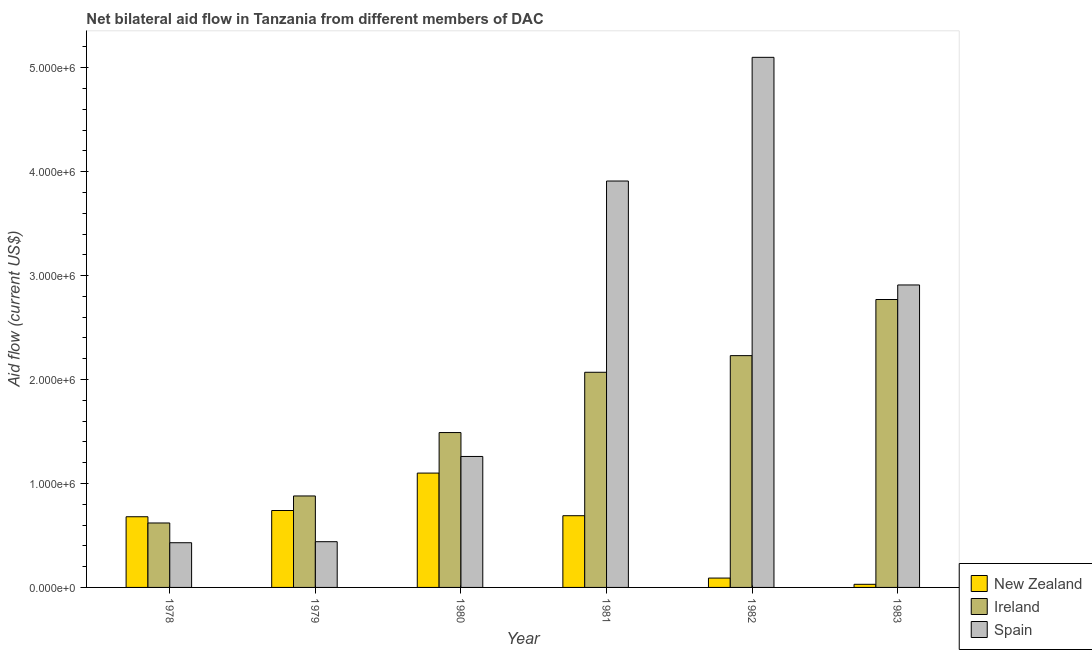How many groups of bars are there?
Offer a very short reply. 6. Are the number of bars per tick equal to the number of legend labels?
Keep it short and to the point. Yes. How many bars are there on the 5th tick from the left?
Offer a terse response. 3. What is the label of the 3rd group of bars from the left?
Your answer should be very brief. 1980. What is the amount of aid provided by spain in 1980?
Provide a short and direct response. 1.26e+06. Across all years, what is the maximum amount of aid provided by spain?
Give a very brief answer. 5.10e+06. Across all years, what is the minimum amount of aid provided by ireland?
Keep it short and to the point. 6.20e+05. In which year was the amount of aid provided by ireland minimum?
Offer a terse response. 1978. What is the total amount of aid provided by spain in the graph?
Make the answer very short. 1.40e+07. What is the difference between the amount of aid provided by ireland in 1981 and that in 1982?
Offer a terse response. -1.60e+05. What is the difference between the amount of aid provided by new zealand in 1980 and the amount of aid provided by ireland in 1981?
Offer a terse response. 4.10e+05. What is the average amount of aid provided by spain per year?
Give a very brief answer. 2.34e+06. In how many years, is the amount of aid provided by new zealand greater than 2000000 US$?
Make the answer very short. 0. What is the ratio of the amount of aid provided by ireland in 1982 to that in 1983?
Offer a terse response. 0.81. Is the difference between the amount of aid provided by spain in 1980 and 1982 greater than the difference between the amount of aid provided by new zealand in 1980 and 1982?
Provide a short and direct response. No. What is the difference between the highest and the second highest amount of aid provided by new zealand?
Your answer should be very brief. 3.60e+05. What is the difference between the highest and the lowest amount of aid provided by spain?
Provide a short and direct response. 4.67e+06. What does the 3rd bar from the right in 1983 represents?
Provide a short and direct response. New Zealand. Are the values on the major ticks of Y-axis written in scientific E-notation?
Offer a terse response. Yes. Does the graph contain any zero values?
Your answer should be compact. No. Does the graph contain grids?
Your response must be concise. No. What is the title of the graph?
Your answer should be compact. Net bilateral aid flow in Tanzania from different members of DAC. Does "Male employers" appear as one of the legend labels in the graph?
Give a very brief answer. No. What is the label or title of the X-axis?
Ensure brevity in your answer.  Year. What is the label or title of the Y-axis?
Ensure brevity in your answer.  Aid flow (current US$). What is the Aid flow (current US$) in New Zealand in 1978?
Ensure brevity in your answer.  6.80e+05. What is the Aid flow (current US$) in Ireland in 1978?
Give a very brief answer. 6.20e+05. What is the Aid flow (current US$) in New Zealand in 1979?
Your answer should be very brief. 7.40e+05. What is the Aid flow (current US$) in Ireland in 1979?
Your answer should be compact. 8.80e+05. What is the Aid flow (current US$) of New Zealand in 1980?
Offer a terse response. 1.10e+06. What is the Aid flow (current US$) of Ireland in 1980?
Keep it short and to the point. 1.49e+06. What is the Aid flow (current US$) in Spain in 1980?
Offer a terse response. 1.26e+06. What is the Aid flow (current US$) of New Zealand in 1981?
Your response must be concise. 6.90e+05. What is the Aid flow (current US$) of Ireland in 1981?
Offer a very short reply. 2.07e+06. What is the Aid flow (current US$) in Spain in 1981?
Make the answer very short. 3.91e+06. What is the Aid flow (current US$) of Ireland in 1982?
Keep it short and to the point. 2.23e+06. What is the Aid flow (current US$) in Spain in 1982?
Provide a succinct answer. 5.10e+06. What is the Aid flow (current US$) of New Zealand in 1983?
Your response must be concise. 3.00e+04. What is the Aid flow (current US$) in Ireland in 1983?
Make the answer very short. 2.77e+06. What is the Aid flow (current US$) of Spain in 1983?
Keep it short and to the point. 2.91e+06. Across all years, what is the maximum Aid flow (current US$) of New Zealand?
Provide a succinct answer. 1.10e+06. Across all years, what is the maximum Aid flow (current US$) of Ireland?
Keep it short and to the point. 2.77e+06. Across all years, what is the maximum Aid flow (current US$) of Spain?
Make the answer very short. 5.10e+06. Across all years, what is the minimum Aid flow (current US$) in Ireland?
Offer a terse response. 6.20e+05. What is the total Aid flow (current US$) in New Zealand in the graph?
Keep it short and to the point. 3.33e+06. What is the total Aid flow (current US$) of Ireland in the graph?
Make the answer very short. 1.01e+07. What is the total Aid flow (current US$) of Spain in the graph?
Your answer should be very brief. 1.40e+07. What is the difference between the Aid flow (current US$) of New Zealand in 1978 and that in 1980?
Keep it short and to the point. -4.20e+05. What is the difference between the Aid flow (current US$) of Ireland in 1978 and that in 1980?
Offer a terse response. -8.70e+05. What is the difference between the Aid flow (current US$) in Spain in 1978 and that in 1980?
Offer a terse response. -8.30e+05. What is the difference between the Aid flow (current US$) in Ireland in 1978 and that in 1981?
Your response must be concise. -1.45e+06. What is the difference between the Aid flow (current US$) of Spain in 1978 and that in 1981?
Give a very brief answer. -3.48e+06. What is the difference between the Aid flow (current US$) of New Zealand in 1978 and that in 1982?
Ensure brevity in your answer.  5.90e+05. What is the difference between the Aid flow (current US$) of Ireland in 1978 and that in 1982?
Your response must be concise. -1.61e+06. What is the difference between the Aid flow (current US$) in Spain in 1978 and that in 1982?
Provide a succinct answer. -4.67e+06. What is the difference between the Aid flow (current US$) in New Zealand in 1978 and that in 1983?
Your answer should be compact. 6.50e+05. What is the difference between the Aid flow (current US$) of Ireland in 1978 and that in 1983?
Your answer should be compact. -2.15e+06. What is the difference between the Aid flow (current US$) of Spain in 1978 and that in 1983?
Offer a very short reply. -2.48e+06. What is the difference between the Aid flow (current US$) of New Zealand in 1979 and that in 1980?
Provide a short and direct response. -3.60e+05. What is the difference between the Aid flow (current US$) in Ireland in 1979 and that in 1980?
Your response must be concise. -6.10e+05. What is the difference between the Aid flow (current US$) in Spain in 1979 and that in 1980?
Keep it short and to the point. -8.20e+05. What is the difference between the Aid flow (current US$) in New Zealand in 1979 and that in 1981?
Keep it short and to the point. 5.00e+04. What is the difference between the Aid flow (current US$) in Ireland in 1979 and that in 1981?
Offer a terse response. -1.19e+06. What is the difference between the Aid flow (current US$) of Spain in 1979 and that in 1981?
Offer a terse response. -3.47e+06. What is the difference between the Aid flow (current US$) in New Zealand in 1979 and that in 1982?
Offer a very short reply. 6.50e+05. What is the difference between the Aid flow (current US$) in Ireland in 1979 and that in 1982?
Keep it short and to the point. -1.35e+06. What is the difference between the Aid flow (current US$) of Spain in 1979 and that in 1982?
Your answer should be very brief. -4.66e+06. What is the difference between the Aid flow (current US$) in New Zealand in 1979 and that in 1983?
Provide a short and direct response. 7.10e+05. What is the difference between the Aid flow (current US$) in Ireland in 1979 and that in 1983?
Keep it short and to the point. -1.89e+06. What is the difference between the Aid flow (current US$) of Spain in 1979 and that in 1983?
Keep it short and to the point. -2.47e+06. What is the difference between the Aid flow (current US$) in New Zealand in 1980 and that in 1981?
Your answer should be very brief. 4.10e+05. What is the difference between the Aid flow (current US$) in Ireland in 1980 and that in 1981?
Keep it short and to the point. -5.80e+05. What is the difference between the Aid flow (current US$) of Spain in 1980 and that in 1981?
Ensure brevity in your answer.  -2.65e+06. What is the difference between the Aid flow (current US$) in New Zealand in 1980 and that in 1982?
Provide a short and direct response. 1.01e+06. What is the difference between the Aid flow (current US$) of Ireland in 1980 and that in 1982?
Offer a very short reply. -7.40e+05. What is the difference between the Aid flow (current US$) in Spain in 1980 and that in 1982?
Your answer should be very brief. -3.84e+06. What is the difference between the Aid flow (current US$) of New Zealand in 1980 and that in 1983?
Your response must be concise. 1.07e+06. What is the difference between the Aid flow (current US$) in Ireland in 1980 and that in 1983?
Offer a terse response. -1.28e+06. What is the difference between the Aid flow (current US$) in Spain in 1980 and that in 1983?
Give a very brief answer. -1.65e+06. What is the difference between the Aid flow (current US$) of Spain in 1981 and that in 1982?
Your response must be concise. -1.19e+06. What is the difference between the Aid flow (current US$) of New Zealand in 1981 and that in 1983?
Your answer should be very brief. 6.60e+05. What is the difference between the Aid flow (current US$) of Ireland in 1981 and that in 1983?
Keep it short and to the point. -7.00e+05. What is the difference between the Aid flow (current US$) in Ireland in 1982 and that in 1983?
Keep it short and to the point. -5.40e+05. What is the difference between the Aid flow (current US$) in Spain in 1982 and that in 1983?
Offer a terse response. 2.19e+06. What is the difference between the Aid flow (current US$) of New Zealand in 1978 and the Aid flow (current US$) of Ireland in 1980?
Provide a succinct answer. -8.10e+05. What is the difference between the Aid flow (current US$) of New Zealand in 1978 and the Aid flow (current US$) of Spain in 1980?
Your response must be concise. -5.80e+05. What is the difference between the Aid flow (current US$) of Ireland in 1978 and the Aid flow (current US$) of Spain in 1980?
Offer a very short reply. -6.40e+05. What is the difference between the Aid flow (current US$) of New Zealand in 1978 and the Aid flow (current US$) of Ireland in 1981?
Your answer should be compact. -1.39e+06. What is the difference between the Aid flow (current US$) in New Zealand in 1978 and the Aid flow (current US$) in Spain in 1981?
Offer a terse response. -3.23e+06. What is the difference between the Aid flow (current US$) in Ireland in 1978 and the Aid flow (current US$) in Spain in 1981?
Your answer should be very brief. -3.29e+06. What is the difference between the Aid flow (current US$) in New Zealand in 1978 and the Aid flow (current US$) in Ireland in 1982?
Make the answer very short. -1.55e+06. What is the difference between the Aid flow (current US$) in New Zealand in 1978 and the Aid flow (current US$) in Spain in 1982?
Offer a terse response. -4.42e+06. What is the difference between the Aid flow (current US$) in Ireland in 1978 and the Aid flow (current US$) in Spain in 1982?
Provide a succinct answer. -4.48e+06. What is the difference between the Aid flow (current US$) of New Zealand in 1978 and the Aid flow (current US$) of Ireland in 1983?
Ensure brevity in your answer.  -2.09e+06. What is the difference between the Aid flow (current US$) of New Zealand in 1978 and the Aid flow (current US$) of Spain in 1983?
Your response must be concise. -2.23e+06. What is the difference between the Aid flow (current US$) in Ireland in 1978 and the Aid flow (current US$) in Spain in 1983?
Give a very brief answer. -2.29e+06. What is the difference between the Aid flow (current US$) of New Zealand in 1979 and the Aid flow (current US$) of Ireland in 1980?
Offer a terse response. -7.50e+05. What is the difference between the Aid flow (current US$) in New Zealand in 1979 and the Aid flow (current US$) in Spain in 1980?
Offer a very short reply. -5.20e+05. What is the difference between the Aid flow (current US$) in Ireland in 1979 and the Aid flow (current US$) in Spain in 1980?
Offer a very short reply. -3.80e+05. What is the difference between the Aid flow (current US$) of New Zealand in 1979 and the Aid flow (current US$) of Ireland in 1981?
Give a very brief answer. -1.33e+06. What is the difference between the Aid flow (current US$) in New Zealand in 1979 and the Aid flow (current US$) in Spain in 1981?
Your response must be concise. -3.17e+06. What is the difference between the Aid flow (current US$) in Ireland in 1979 and the Aid flow (current US$) in Spain in 1981?
Your answer should be compact. -3.03e+06. What is the difference between the Aid flow (current US$) of New Zealand in 1979 and the Aid flow (current US$) of Ireland in 1982?
Keep it short and to the point. -1.49e+06. What is the difference between the Aid flow (current US$) in New Zealand in 1979 and the Aid flow (current US$) in Spain in 1982?
Give a very brief answer. -4.36e+06. What is the difference between the Aid flow (current US$) in Ireland in 1979 and the Aid flow (current US$) in Spain in 1982?
Give a very brief answer. -4.22e+06. What is the difference between the Aid flow (current US$) of New Zealand in 1979 and the Aid flow (current US$) of Ireland in 1983?
Offer a very short reply. -2.03e+06. What is the difference between the Aid flow (current US$) of New Zealand in 1979 and the Aid flow (current US$) of Spain in 1983?
Provide a succinct answer. -2.17e+06. What is the difference between the Aid flow (current US$) of Ireland in 1979 and the Aid flow (current US$) of Spain in 1983?
Keep it short and to the point. -2.03e+06. What is the difference between the Aid flow (current US$) of New Zealand in 1980 and the Aid flow (current US$) of Ireland in 1981?
Offer a terse response. -9.70e+05. What is the difference between the Aid flow (current US$) in New Zealand in 1980 and the Aid flow (current US$) in Spain in 1981?
Give a very brief answer. -2.81e+06. What is the difference between the Aid flow (current US$) of Ireland in 1980 and the Aid flow (current US$) of Spain in 1981?
Give a very brief answer. -2.42e+06. What is the difference between the Aid flow (current US$) in New Zealand in 1980 and the Aid flow (current US$) in Ireland in 1982?
Your answer should be compact. -1.13e+06. What is the difference between the Aid flow (current US$) of New Zealand in 1980 and the Aid flow (current US$) of Spain in 1982?
Keep it short and to the point. -4.00e+06. What is the difference between the Aid flow (current US$) in Ireland in 1980 and the Aid flow (current US$) in Spain in 1982?
Ensure brevity in your answer.  -3.61e+06. What is the difference between the Aid flow (current US$) of New Zealand in 1980 and the Aid flow (current US$) of Ireland in 1983?
Ensure brevity in your answer.  -1.67e+06. What is the difference between the Aid flow (current US$) in New Zealand in 1980 and the Aid flow (current US$) in Spain in 1983?
Offer a very short reply. -1.81e+06. What is the difference between the Aid flow (current US$) in Ireland in 1980 and the Aid flow (current US$) in Spain in 1983?
Your answer should be very brief. -1.42e+06. What is the difference between the Aid flow (current US$) of New Zealand in 1981 and the Aid flow (current US$) of Ireland in 1982?
Provide a short and direct response. -1.54e+06. What is the difference between the Aid flow (current US$) in New Zealand in 1981 and the Aid flow (current US$) in Spain in 1982?
Your answer should be very brief. -4.41e+06. What is the difference between the Aid flow (current US$) in Ireland in 1981 and the Aid flow (current US$) in Spain in 1982?
Keep it short and to the point. -3.03e+06. What is the difference between the Aid flow (current US$) in New Zealand in 1981 and the Aid flow (current US$) in Ireland in 1983?
Your answer should be compact. -2.08e+06. What is the difference between the Aid flow (current US$) of New Zealand in 1981 and the Aid flow (current US$) of Spain in 1983?
Provide a succinct answer. -2.22e+06. What is the difference between the Aid flow (current US$) in Ireland in 1981 and the Aid flow (current US$) in Spain in 1983?
Give a very brief answer. -8.40e+05. What is the difference between the Aid flow (current US$) in New Zealand in 1982 and the Aid flow (current US$) in Ireland in 1983?
Your response must be concise. -2.68e+06. What is the difference between the Aid flow (current US$) of New Zealand in 1982 and the Aid flow (current US$) of Spain in 1983?
Your answer should be compact. -2.82e+06. What is the difference between the Aid flow (current US$) of Ireland in 1982 and the Aid flow (current US$) of Spain in 1983?
Offer a terse response. -6.80e+05. What is the average Aid flow (current US$) in New Zealand per year?
Provide a short and direct response. 5.55e+05. What is the average Aid flow (current US$) in Ireland per year?
Offer a terse response. 1.68e+06. What is the average Aid flow (current US$) of Spain per year?
Offer a terse response. 2.34e+06. In the year 1978, what is the difference between the Aid flow (current US$) in New Zealand and Aid flow (current US$) in Ireland?
Provide a succinct answer. 6.00e+04. In the year 1978, what is the difference between the Aid flow (current US$) of Ireland and Aid flow (current US$) of Spain?
Make the answer very short. 1.90e+05. In the year 1979, what is the difference between the Aid flow (current US$) of New Zealand and Aid flow (current US$) of Spain?
Ensure brevity in your answer.  3.00e+05. In the year 1980, what is the difference between the Aid flow (current US$) of New Zealand and Aid flow (current US$) of Ireland?
Give a very brief answer. -3.90e+05. In the year 1980, what is the difference between the Aid flow (current US$) in New Zealand and Aid flow (current US$) in Spain?
Give a very brief answer. -1.60e+05. In the year 1981, what is the difference between the Aid flow (current US$) in New Zealand and Aid flow (current US$) in Ireland?
Your answer should be very brief. -1.38e+06. In the year 1981, what is the difference between the Aid flow (current US$) of New Zealand and Aid flow (current US$) of Spain?
Give a very brief answer. -3.22e+06. In the year 1981, what is the difference between the Aid flow (current US$) in Ireland and Aid flow (current US$) in Spain?
Offer a terse response. -1.84e+06. In the year 1982, what is the difference between the Aid flow (current US$) of New Zealand and Aid flow (current US$) of Ireland?
Offer a very short reply. -2.14e+06. In the year 1982, what is the difference between the Aid flow (current US$) in New Zealand and Aid flow (current US$) in Spain?
Ensure brevity in your answer.  -5.01e+06. In the year 1982, what is the difference between the Aid flow (current US$) of Ireland and Aid flow (current US$) of Spain?
Your answer should be very brief. -2.87e+06. In the year 1983, what is the difference between the Aid flow (current US$) in New Zealand and Aid flow (current US$) in Ireland?
Keep it short and to the point. -2.74e+06. In the year 1983, what is the difference between the Aid flow (current US$) of New Zealand and Aid flow (current US$) of Spain?
Your answer should be compact. -2.88e+06. What is the ratio of the Aid flow (current US$) of New Zealand in 1978 to that in 1979?
Provide a succinct answer. 0.92. What is the ratio of the Aid flow (current US$) of Ireland in 1978 to that in 1979?
Make the answer very short. 0.7. What is the ratio of the Aid flow (current US$) in Spain in 1978 to that in 1979?
Keep it short and to the point. 0.98. What is the ratio of the Aid flow (current US$) of New Zealand in 1978 to that in 1980?
Ensure brevity in your answer.  0.62. What is the ratio of the Aid flow (current US$) of Ireland in 1978 to that in 1980?
Your response must be concise. 0.42. What is the ratio of the Aid flow (current US$) of Spain in 1978 to that in 1980?
Give a very brief answer. 0.34. What is the ratio of the Aid flow (current US$) of New Zealand in 1978 to that in 1981?
Your response must be concise. 0.99. What is the ratio of the Aid flow (current US$) of Ireland in 1978 to that in 1981?
Your response must be concise. 0.3. What is the ratio of the Aid flow (current US$) of Spain in 1978 to that in 1981?
Give a very brief answer. 0.11. What is the ratio of the Aid flow (current US$) of New Zealand in 1978 to that in 1982?
Keep it short and to the point. 7.56. What is the ratio of the Aid flow (current US$) in Ireland in 1978 to that in 1982?
Your answer should be very brief. 0.28. What is the ratio of the Aid flow (current US$) of Spain in 1978 to that in 1982?
Your response must be concise. 0.08. What is the ratio of the Aid flow (current US$) of New Zealand in 1978 to that in 1983?
Offer a terse response. 22.67. What is the ratio of the Aid flow (current US$) of Ireland in 1978 to that in 1983?
Ensure brevity in your answer.  0.22. What is the ratio of the Aid flow (current US$) of Spain in 1978 to that in 1983?
Your answer should be very brief. 0.15. What is the ratio of the Aid flow (current US$) of New Zealand in 1979 to that in 1980?
Your response must be concise. 0.67. What is the ratio of the Aid flow (current US$) in Ireland in 1979 to that in 1980?
Offer a very short reply. 0.59. What is the ratio of the Aid flow (current US$) in Spain in 1979 to that in 1980?
Your response must be concise. 0.35. What is the ratio of the Aid flow (current US$) in New Zealand in 1979 to that in 1981?
Your answer should be very brief. 1.07. What is the ratio of the Aid flow (current US$) in Ireland in 1979 to that in 1981?
Offer a terse response. 0.43. What is the ratio of the Aid flow (current US$) of Spain in 1979 to that in 1981?
Offer a terse response. 0.11. What is the ratio of the Aid flow (current US$) of New Zealand in 1979 to that in 1982?
Your answer should be very brief. 8.22. What is the ratio of the Aid flow (current US$) of Ireland in 1979 to that in 1982?
Your response must be concise. 0.39. What is the ratio of the Aid flow (current US$) in Spain in 1979 to that in 1982?
Make the answer very short. 0.09. What is the ratio of the Aid flow (current US$) in New Zealand in 1979 to that in 1983?
Your answer should be compact. 24.67. What is the ratio of the Aid flow (current US$) in Ireland in 1979 to that in 1983?
Make the answer very short. 0.32. What is the ratio of the Aid flow (current US$) of Spain in 1979 to that in 1983?
Your answer should be compact. 0.15. What is the ratio of the Aid flow (current US$) of New Zealand in 1980 to that in 1981?
Provide a short and direct response. 1.59. What is the ratio of the Aid flow (current US$) in Ireland in 1980 to that in 1981?
Make the answer very short. 0.72. What is the ratio of the Aid flow (current US$) in Spain in 1980 to that in 1981?
Your answer should be compact. 0.32. What is the ratio of the Aid flow (current US$) of New Zealand in 1980 to that in 1982?
Provide a short and direct response. 12.22. What is the ratio of the Aid flow (current US$) of Ireland in 1980 to that in 1982?
Offer a terse response. 0.67. What is the ratio of the Aid flow (current US$) of Spain in 1980 to that in 1982?
Ensure brevity in your answer.  0.25. What is the ratio of the Aid flow (current US$) of New Zealand in 1980 to that in 1983?
Keep it short and to the point. 36.67. What is the ratio of the Aid flow (current US$) in Ireland in 1980 to that in 1983?
Provide a short and direct response. 0.54. What is the ratio of the Aid flow (current US$) of Spain in 1980 to that in 1983?
Your answer should be compact. 0.43. What is the ratio of the Aid flow (current US$) of New Zealand in 1981 to that in 1982?
Give a very brief answer. 7.67. What is the ratio of the Aid flow (current US$) in Ireland in 1981 to that in 1982?
Offer a very short reply. 0.93. What is the ratio of the Aid flow (current US$) of Spain in 1981 to that in 1982?
Provide a short and direct response. 0.77. What is the ratio of the Aid flow (current US$) in New Zealand in 1981 to that in 1983?
Make the answer very short. 23. What is the ratio of the Aid flow (current US$) in Ireland in 1981 to that in 1983?
Give a very brief answer. 0.75. What is the ratio of the Aid flow (current US$) in Spain in 1981 to that in 1983?
Your response must be concise. 1.34. What is the ratio of the Aid flow (current US$) in New Zealand in 1982 to that in 1983?
Your answer should be very brief. 3. What is the ratio of the Aid flow (current US$) of Ireland in 1982 to that in 1983?
Provide a succinct answer. 0.81. What is the ratio of the Aid flow (current US$) of Spain in 1982 to that in 1983?
Ensure brevity in your answer.  1.75. What is the difference between the highest and the second highest Aid flow (current US$) of Ireland?
Provide a short and direct response. 5.40e+05. What is the difference between the highest and the second highest Aid flow (current US$) in Spain?
Provide a succinct answer. 1.19e+06. What is the difference between the highest and the lowest Aid flow (current US$) of New Zealand?
Ensure brevity in your answer.  1.07e+06. What is the difference between the highest and the lowest Aid flow (current US$) in Ireland?
Offer a terse response. 2.15e+06. What is the difference between the highest and the lowest Aid flow (current US$) in Spain?
Offer a terse response. 4.67e+06. 